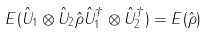Convert formula to latex. <formula><loc_0><loc_0><loc_500><loc_500>E ( \hat { U } _ { 1 } \otimes \hat { U } _ { 2 } \hat { \rho } \hat { U } ^ { \dagger } _ { 1 } \otimes \hat { U } ^ { \dagger } _ { 2 } ) = E ( \hat { \rho } )</formula> 